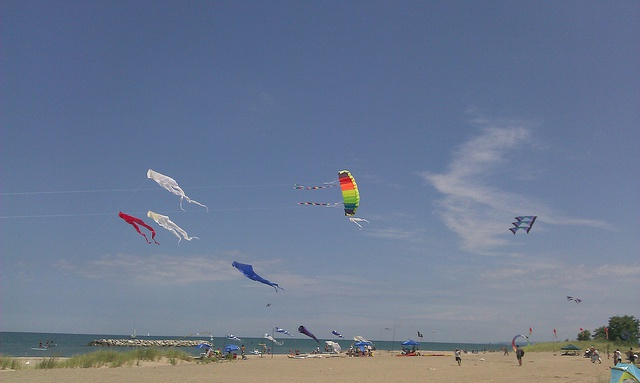Describe the objects in this image and their specific colors. I can see people in blue, tan, and gray tones, kite in blue, darkgray, gray, and lightgray tones, kite in blue, gray, and darkgray tones, kite in blue, darkgray, gray, and lightgray tones, and kite in blue and gray tones in this image. 